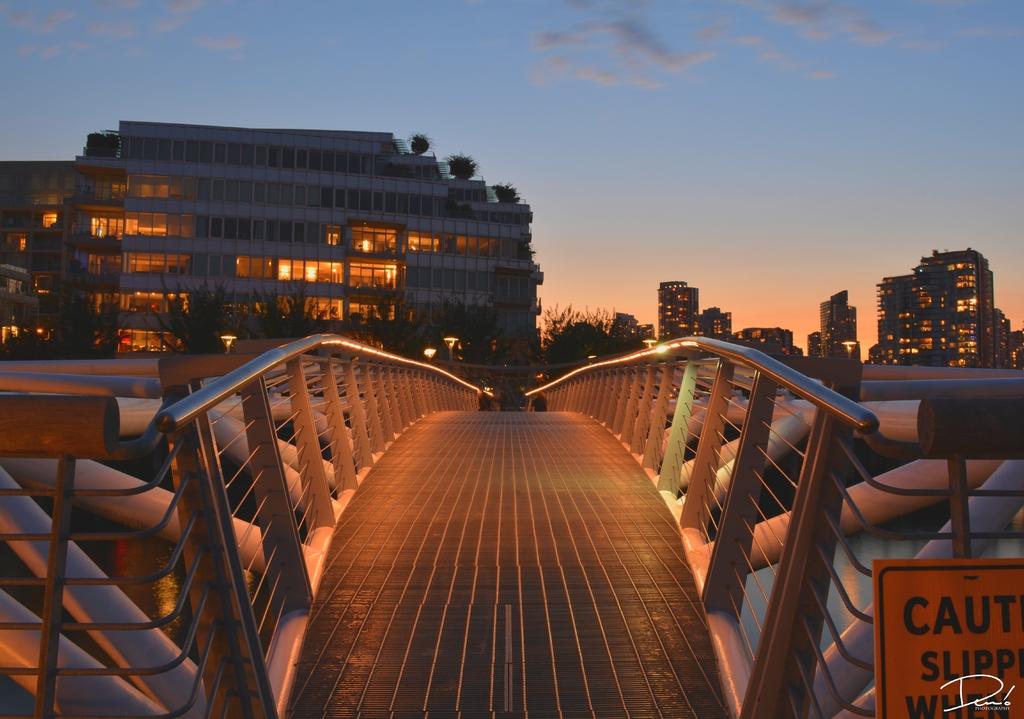What makes the bridge slippery?
Keep it short and to the point. Unanswerable. 